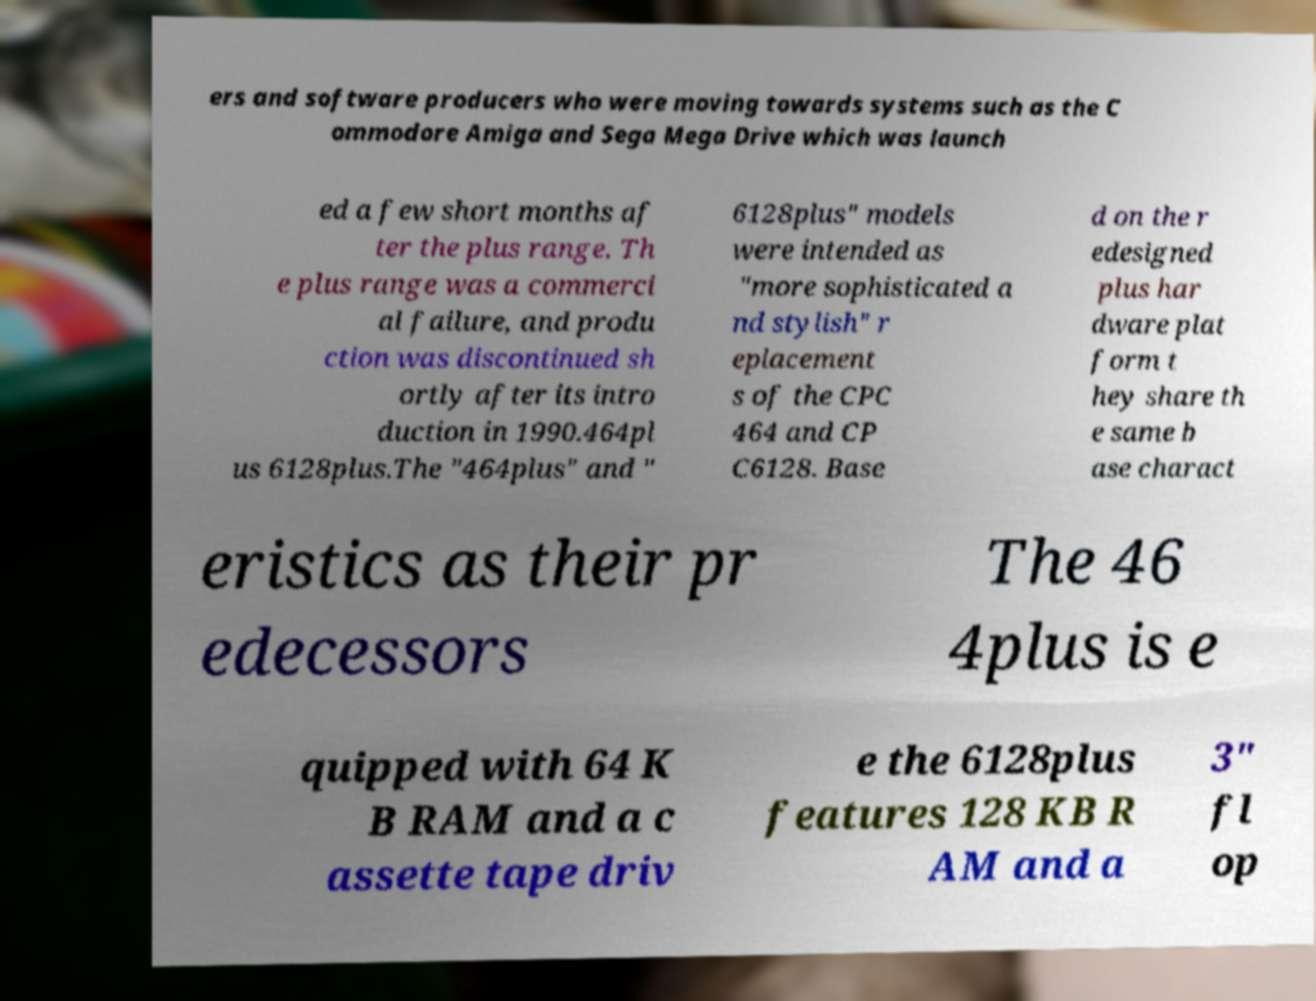Could you assist in decoding the text presented in this image and type it out clearly? ers and software producers who were moving towards systems such as the C ommodore Amiga and Sega Mega Drive which was launch ed a few short months af ter the plus range. Th e plus range was a commerci al failure, and produ ction was discontinued sh ortly after its intro duction in 1990.464pl us 6128plus.The "464plus" and " 6128plus" models were intended as "more sophisticated a nd stylish" r eplacement s of the CPC 464 and CP C6128. Base d on the r edesigned plus har dware plat form t hey share th e same b ase charact eristics as their pr edecessors The 46 4plus is e quipped with 64 K B RAM and a c assette tape driv e the 6128plus features 128 KB R AM and a 3" fl op 